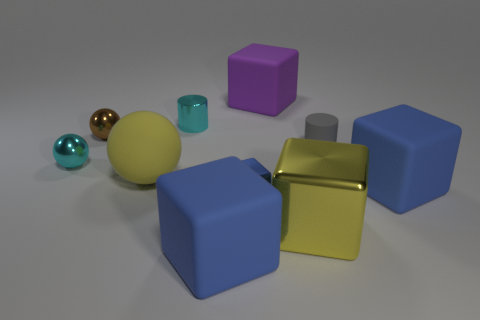Is the color of the cube that is to the right of the gray matte cylinder the same as the small shiny thing in front of the matte ball?
Keep it short and to the point. Yes. Are there more large rubber balls that are behind the purple rubber thing than tiny shiny spheres?
Keep it short and to the point. No. There is a large purple thing that is the same material as the large yellow sphere; what is its shape?
Give a very brief answer. Cube. Does the rubber cube behind the brown metal thing have the same size as the yellow rubber object?
Ensure brevity in your answer.  Yes. What shape is the tiny cyan object in front of the cylinder on the left side of the big yellow metallic object?
Make the answer very short. Sphere. What is the size of the shiny cube that is left of the large yellow thing in front of the yellow sphere?
Give a very brief answer. Small. The big matte cube that is to the right of the tiny gray object is what color?
Offer a terse response. Blue. The brown sphere that is the same material as the large yellow cube is what size?
Your response must be concise. Small. How many tiny cyan metallic things have the same shape as the tiny matte object?
Give a very brief answer. 1. There is a gray cylinder that is the same size as the blue metallic cube; what is it made of?
Give a very brief answer. Rubber. 